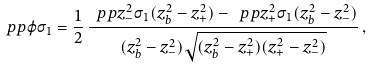<formula> <loc_0><loc_0><loc_500><loc_500>\ p p { \varphi } { \sigma _ { 1 } } = \frac { 1 } { 2 } \, \frac { \ p p { z _ { - } ^ { 2 } } { \sigma _ { 1 } } ( z _ { b } ^ { 2 } - z _ { + } ^ { 2 } ) - \ p p { z _ { + } ^ { 2 } } { \sigma _ { 1 } } ( z _ { b } ^ { 2 } - z _ { - } ^ { 2 } ) } { ( z _ { b } ^ { 2 } - z _ { - } ^ { 2 } ) \sqrt { ( z _ { b } ^ { 2 } - z _ { + } ^ { 2 } ) ( z _ { + } ^ { 2 } - z _ { - } ^ { 2 } ) } } \, ,</formula> 